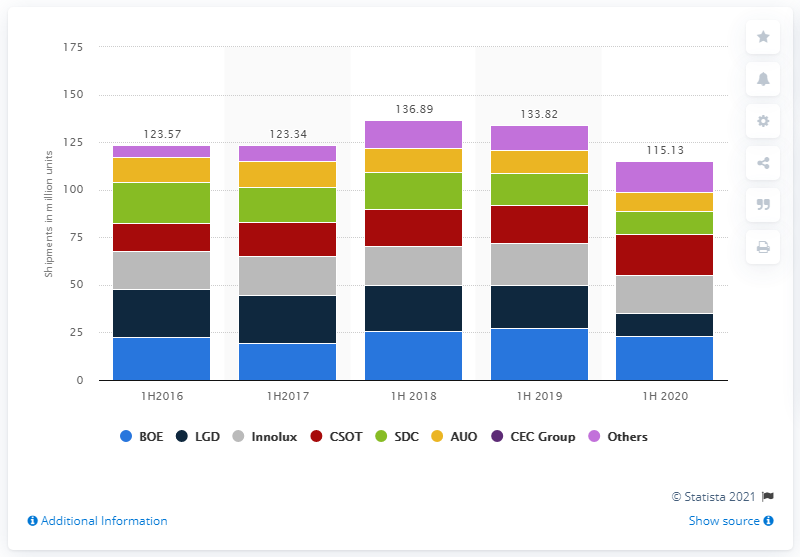Draw attention to some important aspects in this diagram. BOE was the leading LCD panel vendor in the first half of 2020. BOE shipped 23,260 LCD TV panels in the first half of 2020. 